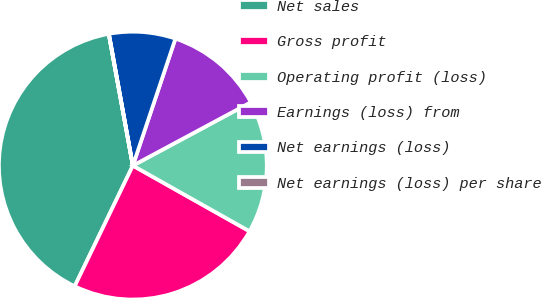Convert chart. <chart><loc_0><loc_0><loc_500><loc_500><pie_chart><fcel>Net sales<fcel>Gross profit<fcel>Operating profit (loss)<fcel>Earnings (loss) from<fcel>Net earnings (loss)<fcel>Net earnings (loss) per share<nl><fcel>39.97%<fcel>23.99%<fcel>16.0%<fcel>12.01%<fcel>8.01%<fcel>0.02%<nl></chart> 